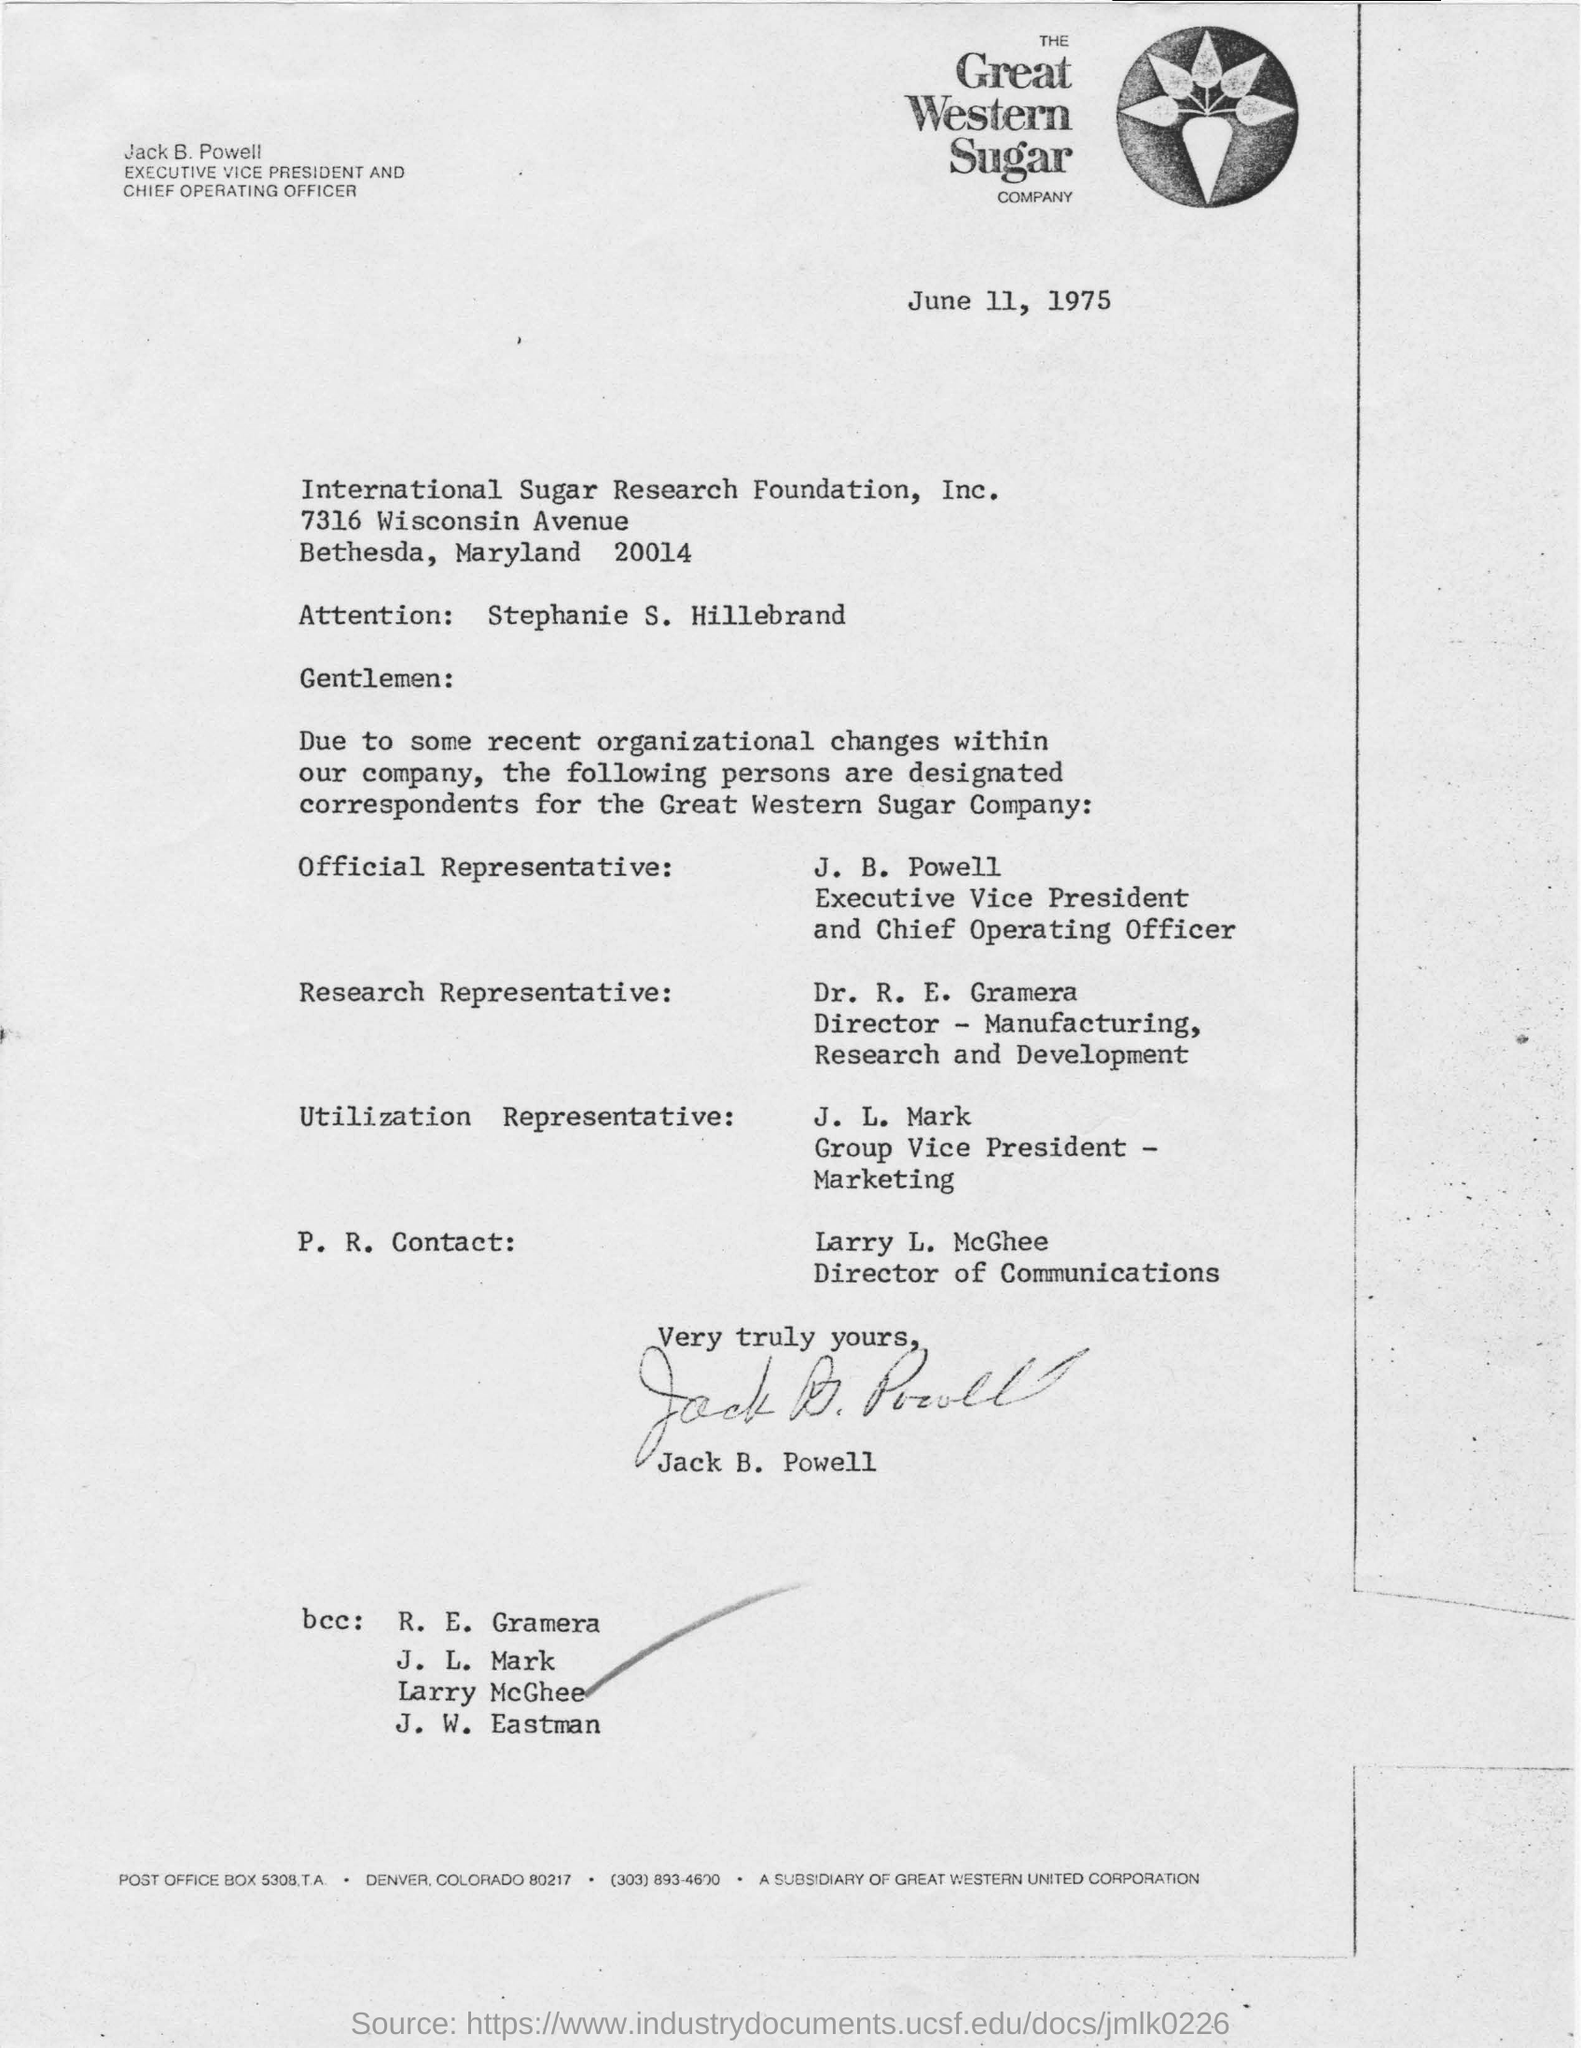What is the letter dated?
Make the answer very short. June 11, 1975. Who has signed the letter?
Keep it short and to the point. Jack B. Powell. What is the designation of J. B. Powell?
Keep it short and to the point. Executive Vice President and Chief Operating Officer. Who is the Director of Communications?
Ensure brevity in your answer.  Larry L. McGhee. 